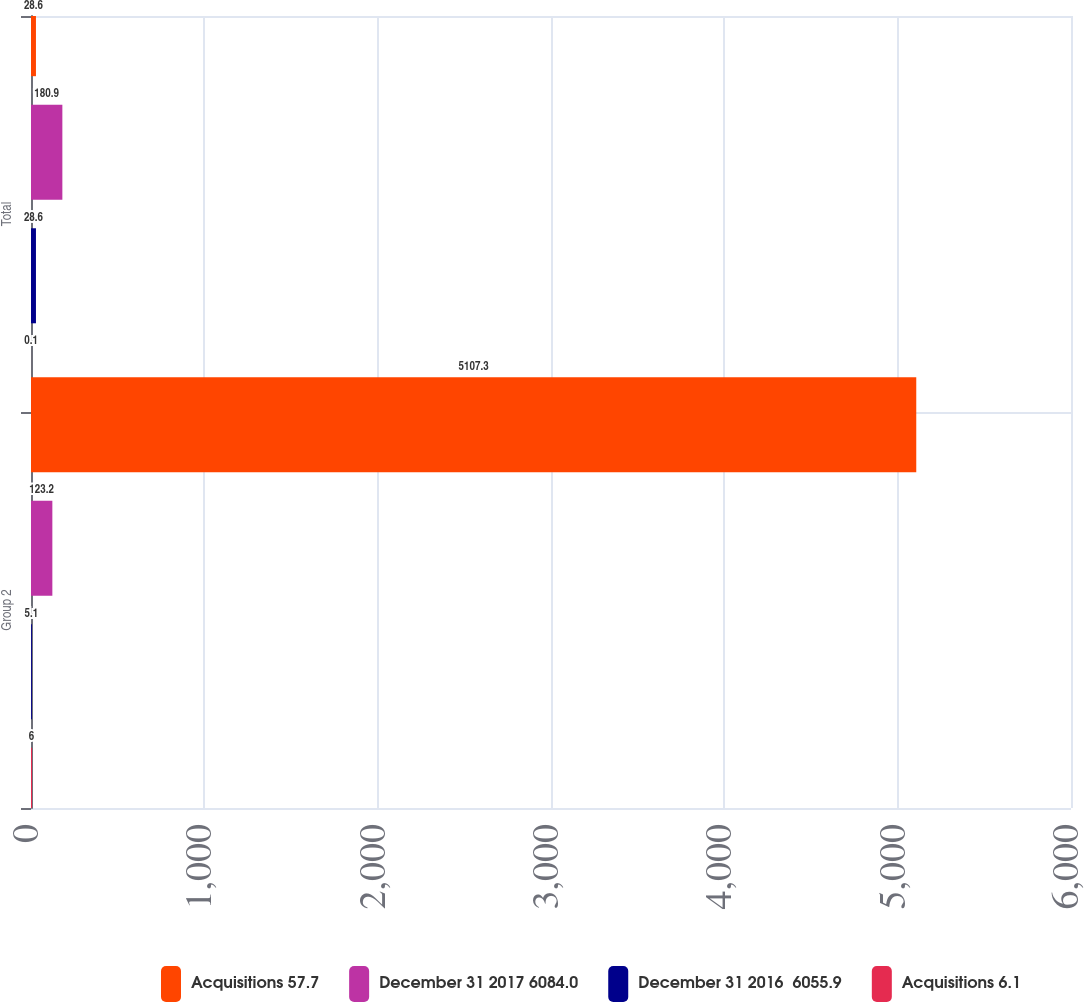Convert chart. <chart><loc_0><loc_0><loc_500><loc_500><stacked_bar_chart><ecel><fcel>Group 2<fcel>Total<nl><fcel>Acquisitions 57.7<fcel>5107.3<fcel>28.6<nl><fcel>December 31 2017 6084.0<fcel>123.2<fcel>180.9<nl><fcel>December 31 2016  6055.9<fcel>5.1<fcel>28.6<nl><fcel>Acquisitions 6.1<fcel>6<fcel>0.1<nl></chart> 